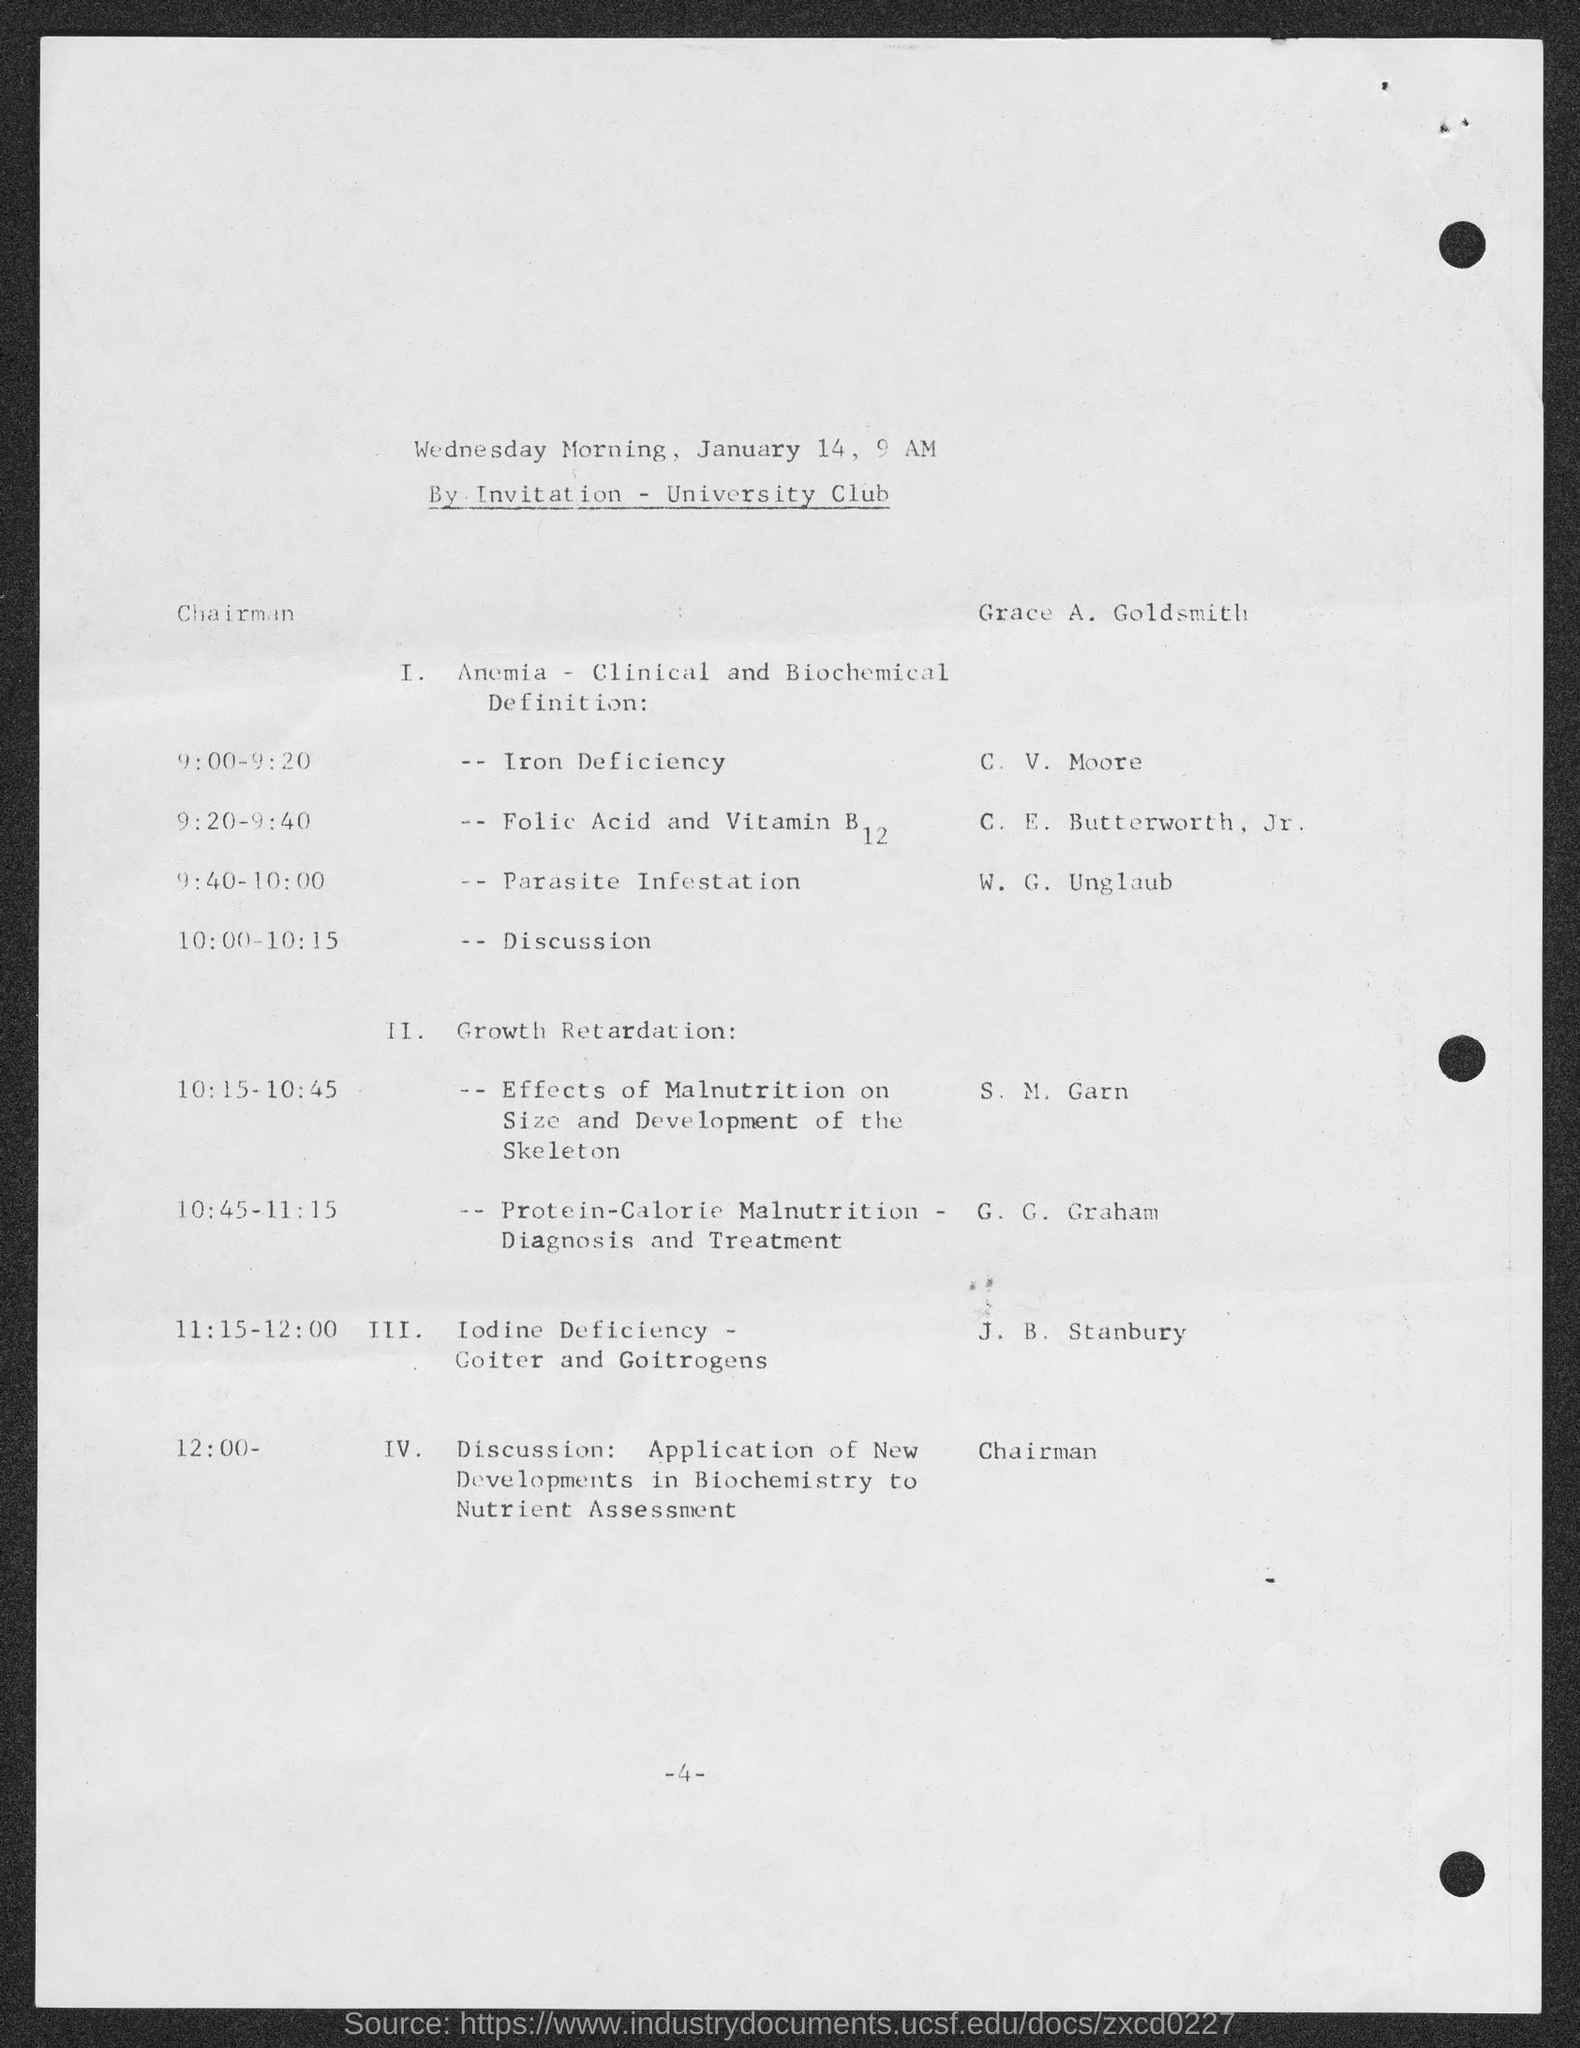Indicate a few pertinent items in this graphic. The number at the bottom of the page is 4. 